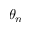Convert formula to latex. <formula><loc_0><loc_0><loc_500><loc_500>\theta _ { n }</formula> 